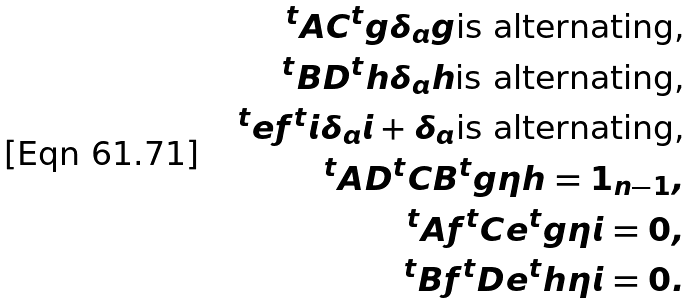<formula> <loc_0><loc_0><loc_500><loc_500>^ { t } A C ^ { t } g \delta _ { a } g \text {is alternating,} \\ ^ { t } B D ^ { t } h \delta _ { a } h \text {is alternating,} \\ ^ { t } e f ^ { t } i \delta _ { a } i + \delta _ { a } \text {is       alternating,} \\ ^ { t } A D ^ { t } C B ^ { t } g \eta h = 1 _ { n - 1 } , \\ ^ { t } A f ^ { t } C e ^ { t } g \eta i = 0 , \\ ^ { t } B f ^ { t } D e ^ { t } h \eta i = 0 .</formula> 